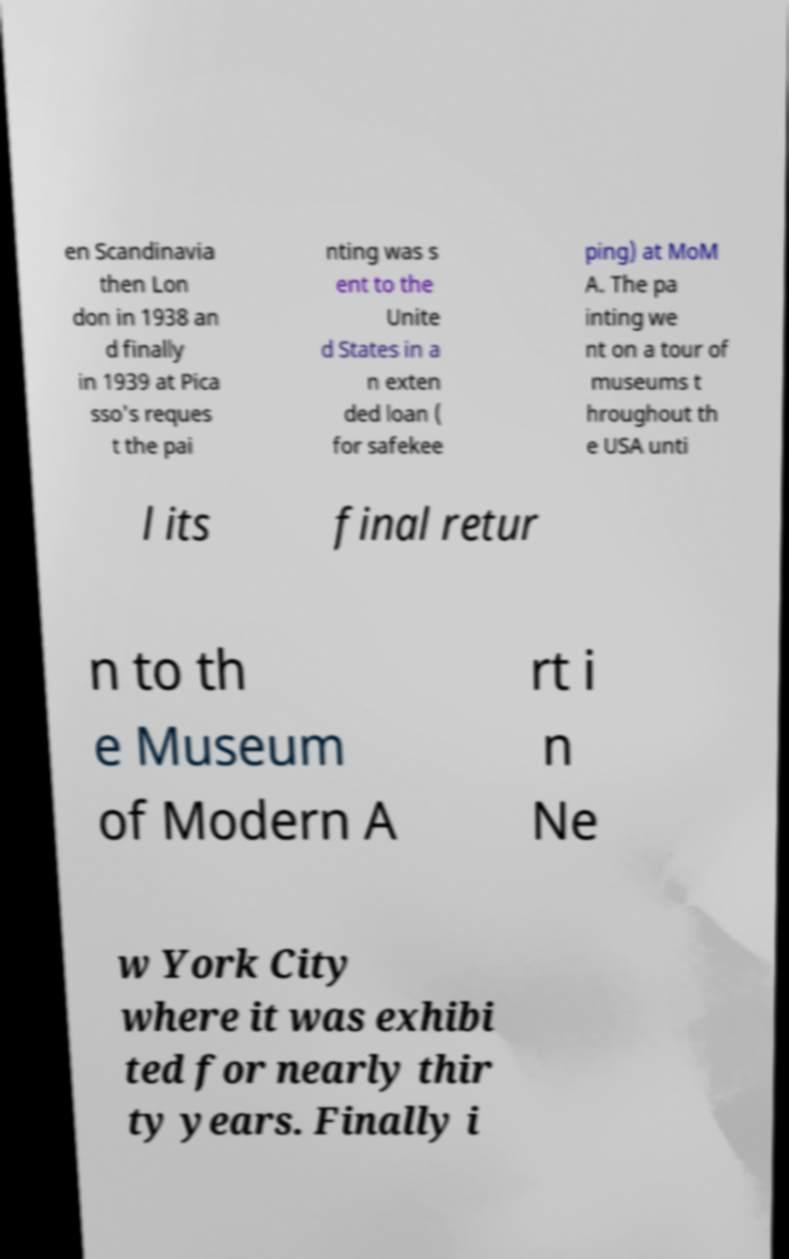For documentation purposes, I need the text within this image transcribed. Could you provide that? en Scandinavia then Lon don in 1938 an d finally in 1939 at Pica sso's reques t the pai nting was s ent to the Unite d States in a n exten ded loan ( for safekee ping) at MoM A. The pa inting we nt on a tour of museums t hroughout th e USA unti l its final retur n to th e Museum of Modern A rt i n Ne w York City where it was exhibi ted for nearly thir ty years. Finally i 